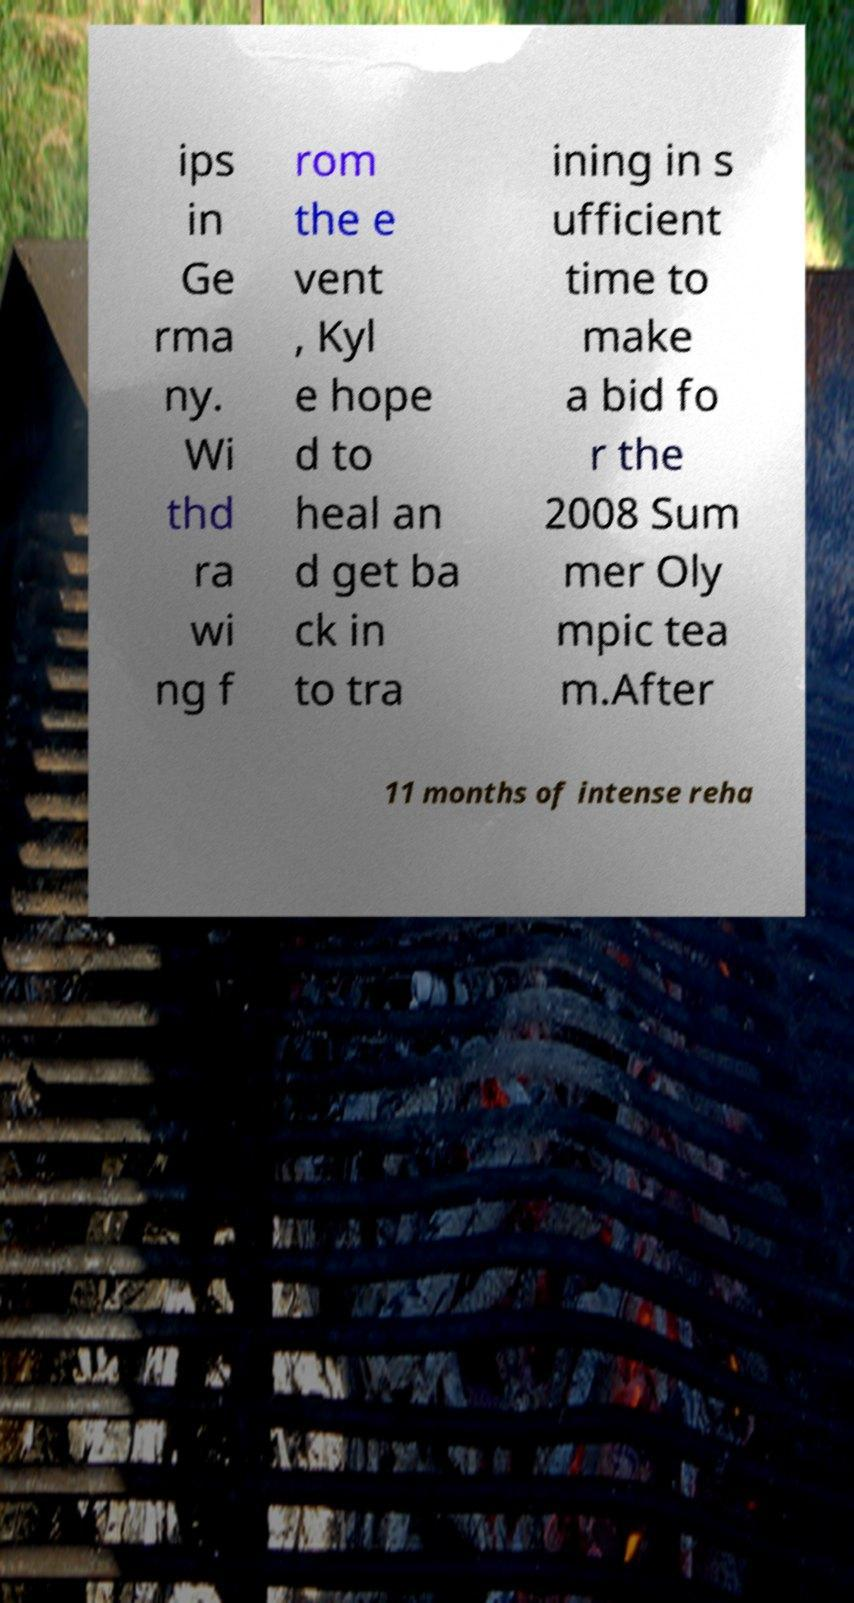I need the written content from this picture converted into text. Can you do that? ips in Ge rma ny. Wi thd ra wi ng f rom the e vent , Kyl e hope d to heal an d get ba ck in to tra ining in s ufficient time to make a bid fo r the 2008 Sum mer Oly mpic tea m.After 11 months of intense reha 